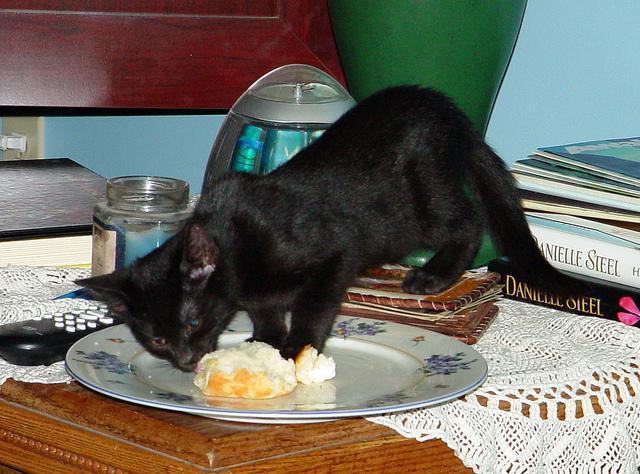How many cats are visible?
Give a very brief answer. 1. How many books are in the picture?
Give a very brief answer. 2. 